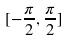Convert formula to latex. <formula><loc_0><loc_0><loc_500><loc_500>[ - \frac { \pi } { 2 } , \frac { \pi } { 2 } ]</formula> 